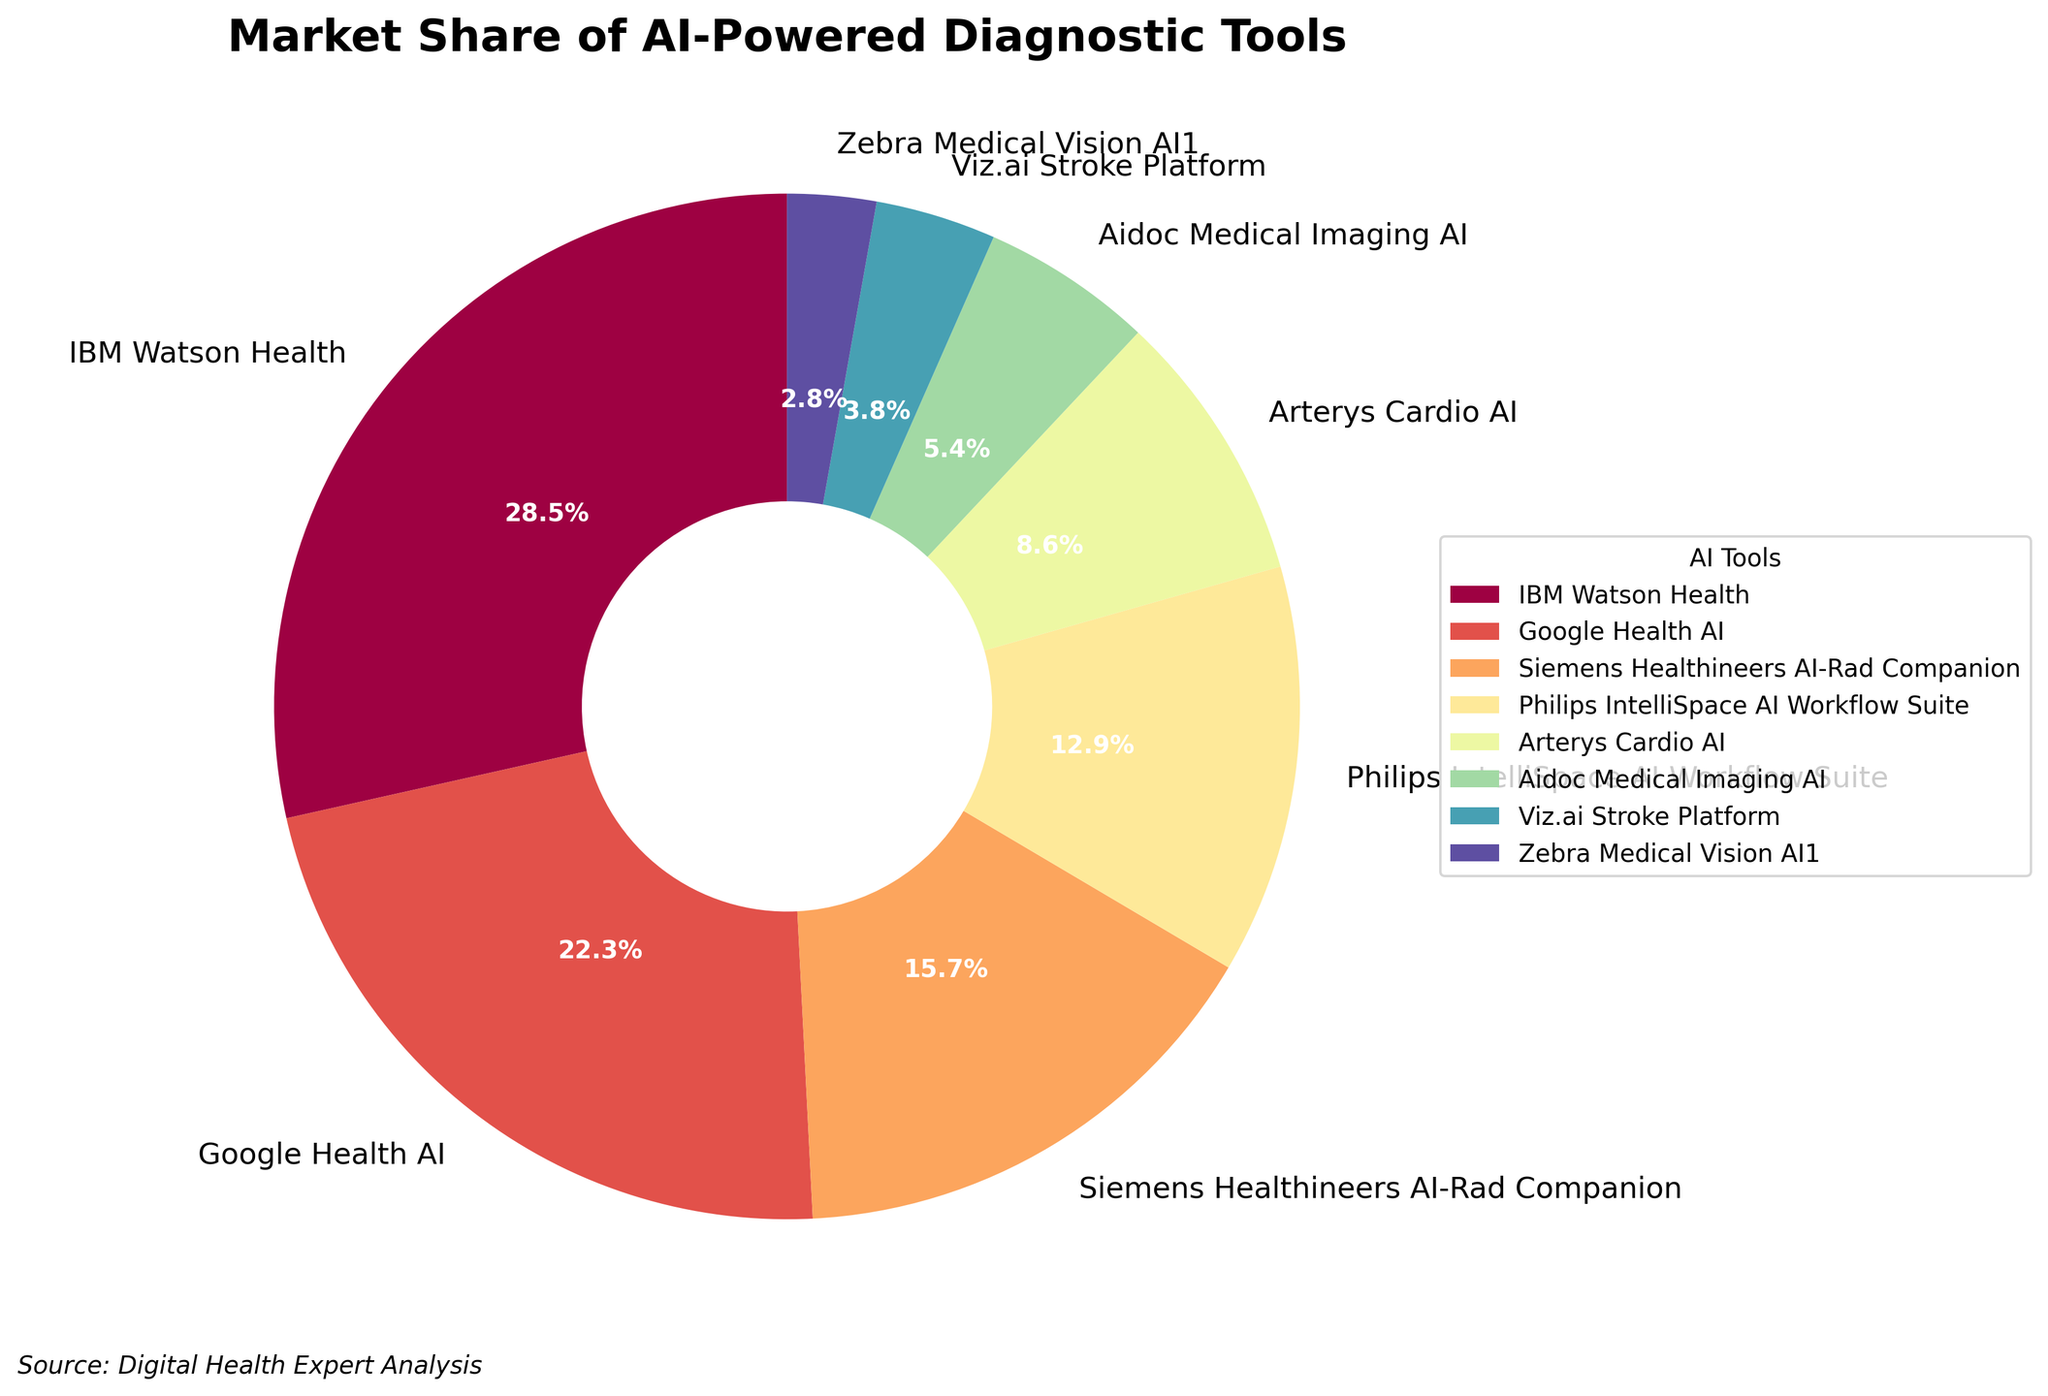What is the market share of IBM Watson Health? IBM Watson Health has a market share of 28.5% as shown in the figure.
Answer: 28.5% Which AI tool has the smallest market share, and what is it? Zebra Medical Vision AI1 is the AI tool with the smallest market share of 2.8%, as shown in the figure.
Answer: Zebra Medical Vision AI1, 2.8% How much greater is the market share of IBM Watson Health compared to that of Google Health AI? IBM Watson Health has a market share of 28.5% and Google Health AI has a market share of 22.3%. The difference is 28.5% - 22.3% = 6.2%.
Answer: 6.2% Which AI tool has the third-largest market share? The third-largest market share is held by Siemens Healthineers AI-Rad Companion with 15.7%.
Answer: Siemens Healthineers AI-Rad Companion What is the combined market share of Philips IntelliSpace AI Workflow Suite and Arterys Cardio AI? Philips IntelliSpace AI Workflow Suite has 12.9% and Arterys Cardio AI has 8.6%. The combined market share is 12.9% + 8.6% = 21.5%.
Answer: 21.5% How do the market shares of Aidoc Medical Imaging AI and Viz.ai Stroke Platform compare? Aidoc Medical Imaging AI has a market share of 5.4%, while Viz.ai Stroke Platform has 3.8%. Aidoc Medical Imaging AI's market share is 1.6% greater.
Answer: 1.6% Which tool's market share is closest to the average market share of all tools? The average market share is the sum of all shares divided by the number of tools: (28.5 + 22.3 + 15.7 + 12.9 + 8.6 + 5.4 + 3.8 + 2.8) / 8 = 12.5%. Philips IntelliSpace AI Workflow Suite at 12.9% is closest to this average.
Answer: Philips IntelliSpace AI Workflow Suite What's the total market share of the top three AI tools? The top three AI tools are IBM Watson Health (28.5%), Google Health AI (22.3%), and Siemens Healthineers AI-Rad Companion (15.7%). Their total market share is 28.5% + 22.3% + 15.7% = 66.5%.
Answer: 66.5% Which AI tools have market shares less than 10%? The AI tools with less than 10% market share are Arterys Cardio AI (8.6%), Aidoc Medical Imaging AI (5.4%), Viz.ai Stroke Platform (3.8%), and Zebra Medical Vision AI1 (2.8%).
Answer: Arterys Cardio AI, Aidoc Medical Imaging AI, Viz.ai Stroke Platform, Zebra Medical Vision AI1 